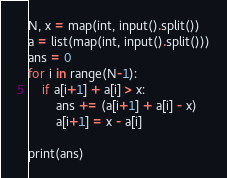Convert code to text. <code><loc_0><loc_0><loc_500><loc_500><_Python_>N, x = map(int, input().split())
a = list(map(int, input().split()))
ans = 0
for i in range(N-1):
    if a[i+1] + a[i] > x:
        ans += (a[i+1] + a[i] - x)
        a[i+1] = x - a[i]

print(ans)
</code> 